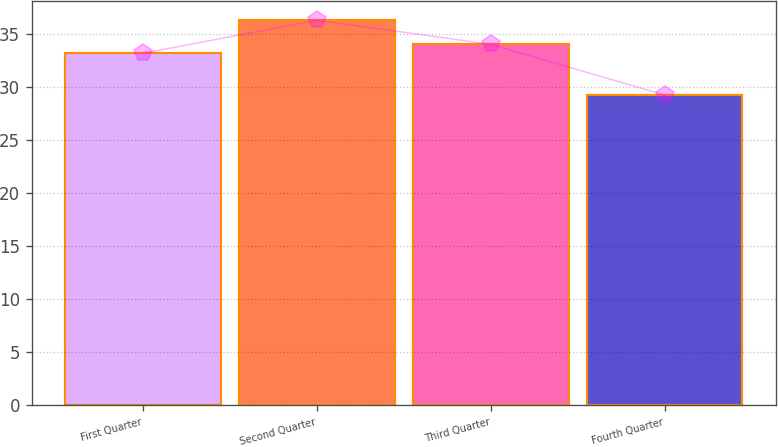<chart> <loc_0><loc_0><loc_500><loc_500><bar_chart><fcel>First Quarter<fcel>Second Quarter<fcel>Third Quarter<fcel>Fourth Quarter<nl><fcel>33.18<fcel>36.29<fcel>34.02<fcel>29.23<nl></chart> 